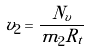<formula> <loc_0><loc_0><loc_500><loc_500>v _ { 2 } = \frac { N _ { v } } { m _ { 2 } R _ { t } }</formula> 